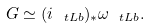Convert formula to latex. <formula><loc_0><loc_0><loc_500><loc_500>G \simeq ( i _ { \ t L b } ) _ { * } \omega _ { \ t L b } .</formula> 